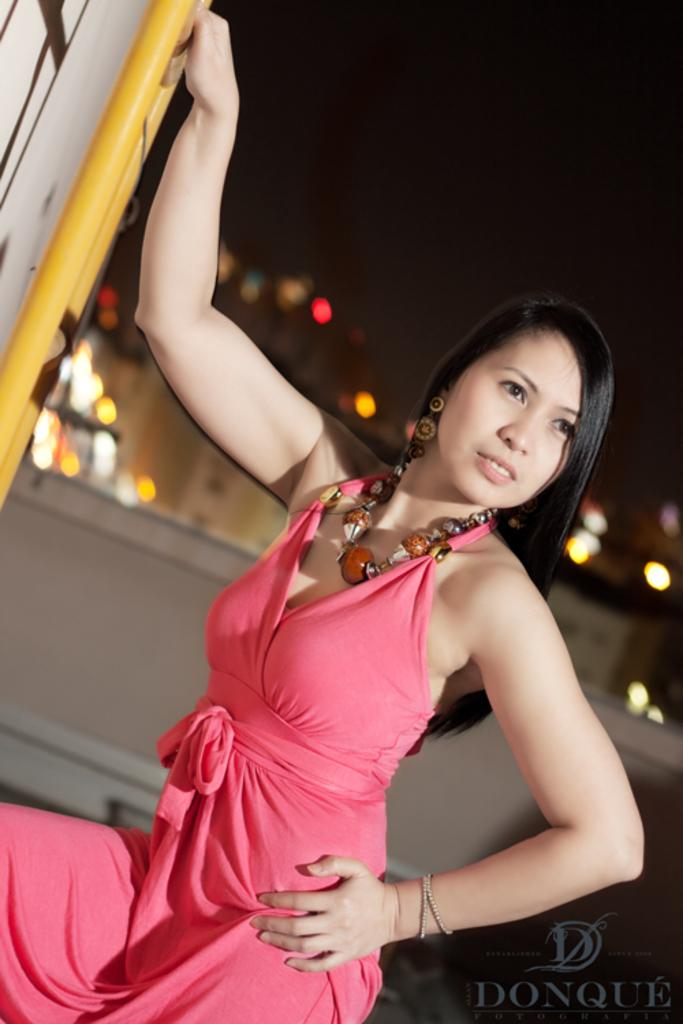Who is the main subject in the image? There is a woman in the image. What is the woman wearing? The woman is wearing a pink dress and a necklace. Can you describe the background of the image? The background of the image is blurred. What invention can be seen in the woman's hands in the image? There is no invention visible in the woman's hands in the image. What type of skirt is the woman wearing in the image? The woman is not wearing a skirt in the image; she is wearing a pink dress. 